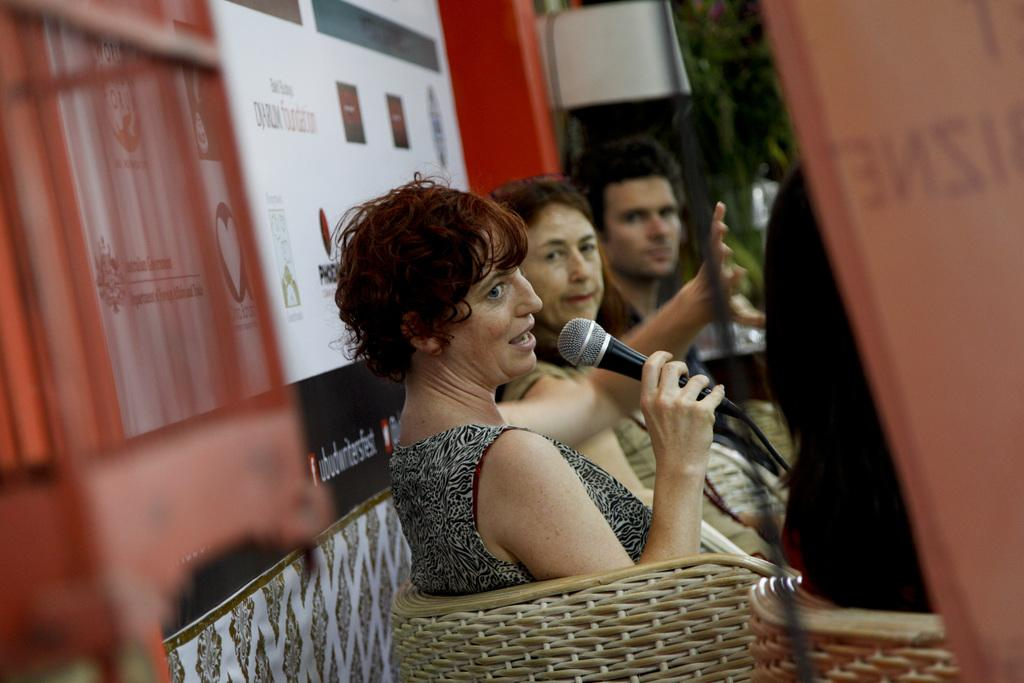What is happening in the image involving a group of people? There is a group of people in the image, and a woman is speaking in the middle of the group. How is the woman addressing the group? The woman is using a microphone to address the group. What is the seating arrangement for the people in the image? The people are seated on chairs. What type of nut is being passed around by the cat in the image? There is no cat or nut present in the image. 